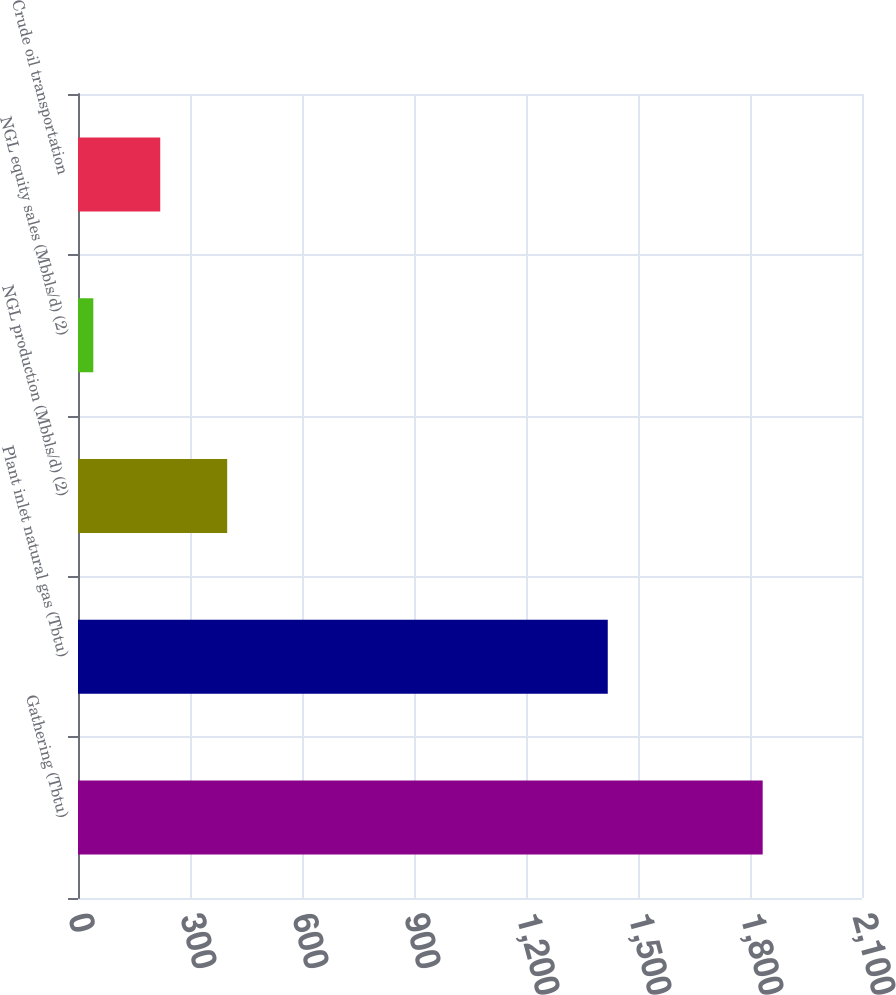Convert chart. <chart><loc_0><loc_0><loc_500><loc_500><bar_chart><fcel>Gathering (Tbtu)<fcel>Plant inlet natural gas (Tbtu)<fcel>NGL production (Mbbls/d) (2)<fcel>NGL equity sales (Mbbls/d) (2)<fcel>Crude oil transportation<nl><fcel>1834<fcel>1419<fcel>399.6<fcel>41<fcel>220.3<nl></chart> 